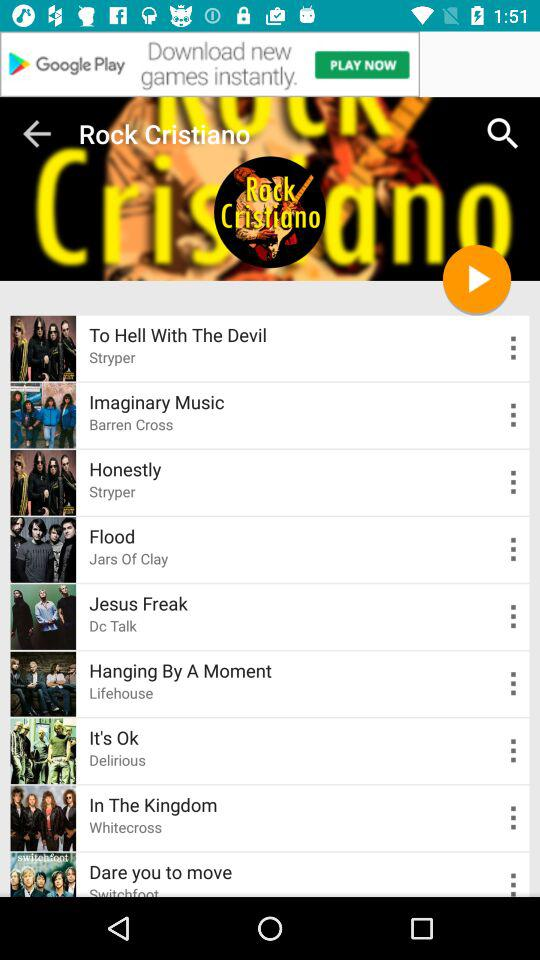What is the album of honestly?
When the provided information is insufficient, respond with <no answer>. <no answer> 